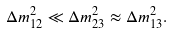Convert formula to latex. <formula><loc_0><loc_0><loc_500><loc_500>\Delta m _ { 1 2 } ^ { 2 } \ll \Delta m _ { 2 3 } ^ { 2 } \approx \Delta m _ { 1 3 } ^ { 2 } .</formula> 